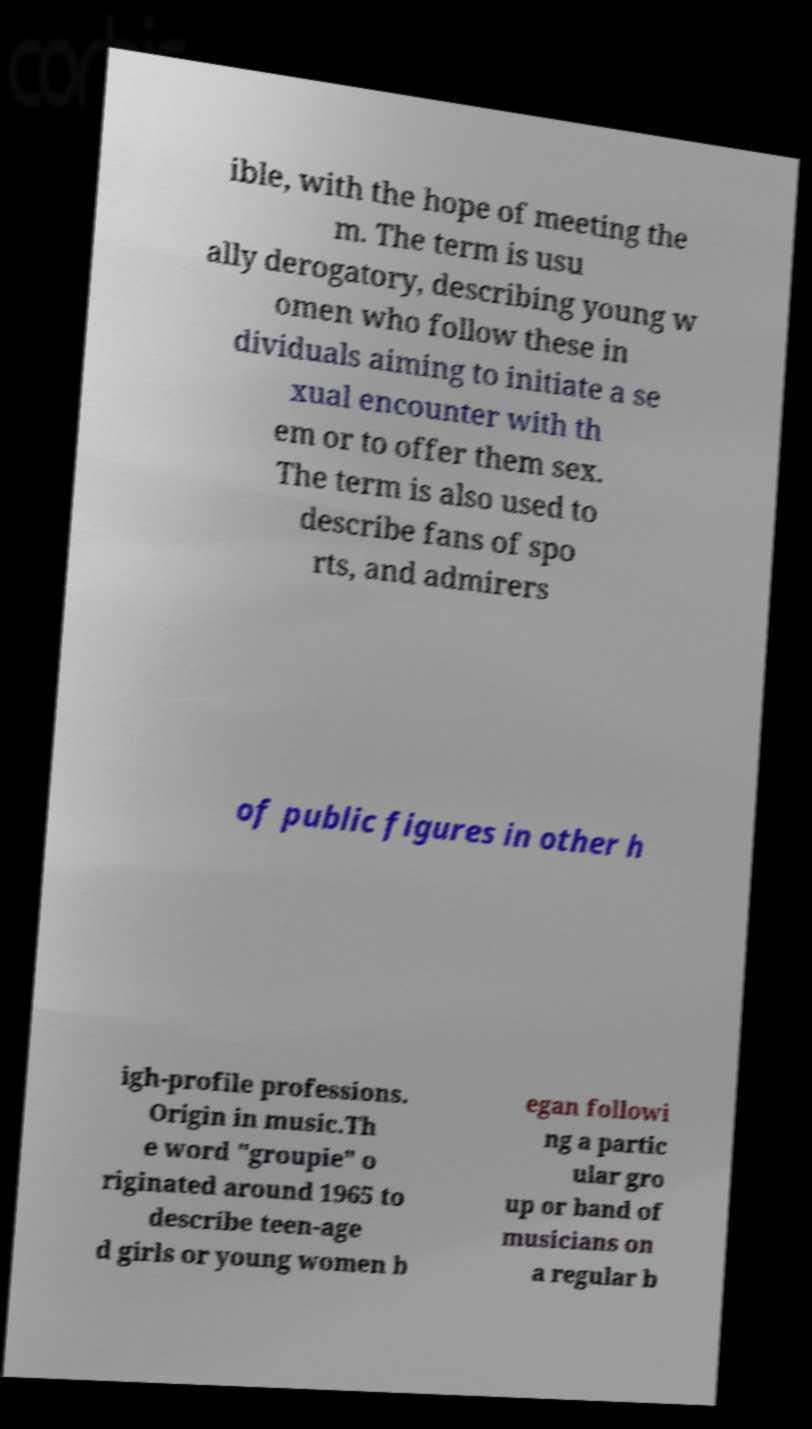Please read and relay the text visible in this image. What does it say? ible, with the hope of meeting the m. The term is usu ally derogatory, describing young w omen who follow these in dividuals aiming to initiate a se xual encounter with th em or to offer them sex. The term is also used to describe fans of spo rts, and admirers of public figures in other h igh-profile professions. Origin in music.Th e word "groupie" o riginated around 1965 to describe teen-age d girls or young women b egan followi ng a partic ular gro up or band of musicians on a regular b 